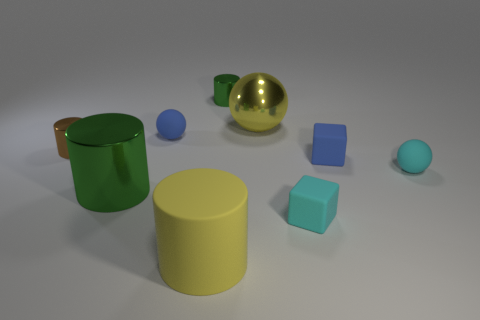How many green cylinders must be subtracted to get 1 green cylinders? 1 Subtract all cylinders. How many objects are left? 5 Subtract 3 cylinders. How many cylinders are left? 1 Subtract all yellow cylinders. Subtract all blue balls. How many cylinders are left? 3 Subtract all cyan spheres. How many cyan cubes are left? 1 Subtract all yellow matte objects. Subtract all small shiny objects. How many objects are left? 6 Add 3 tiny blue rubber blocks. How many tiny blue rubber blocks are left? 4 Add 6 big balls. How many big balls exist? 7 Subtract all yellow spheres. How many spheres are left? 2 Subtract all shiny cylinders. How many cylinders are left? 1 